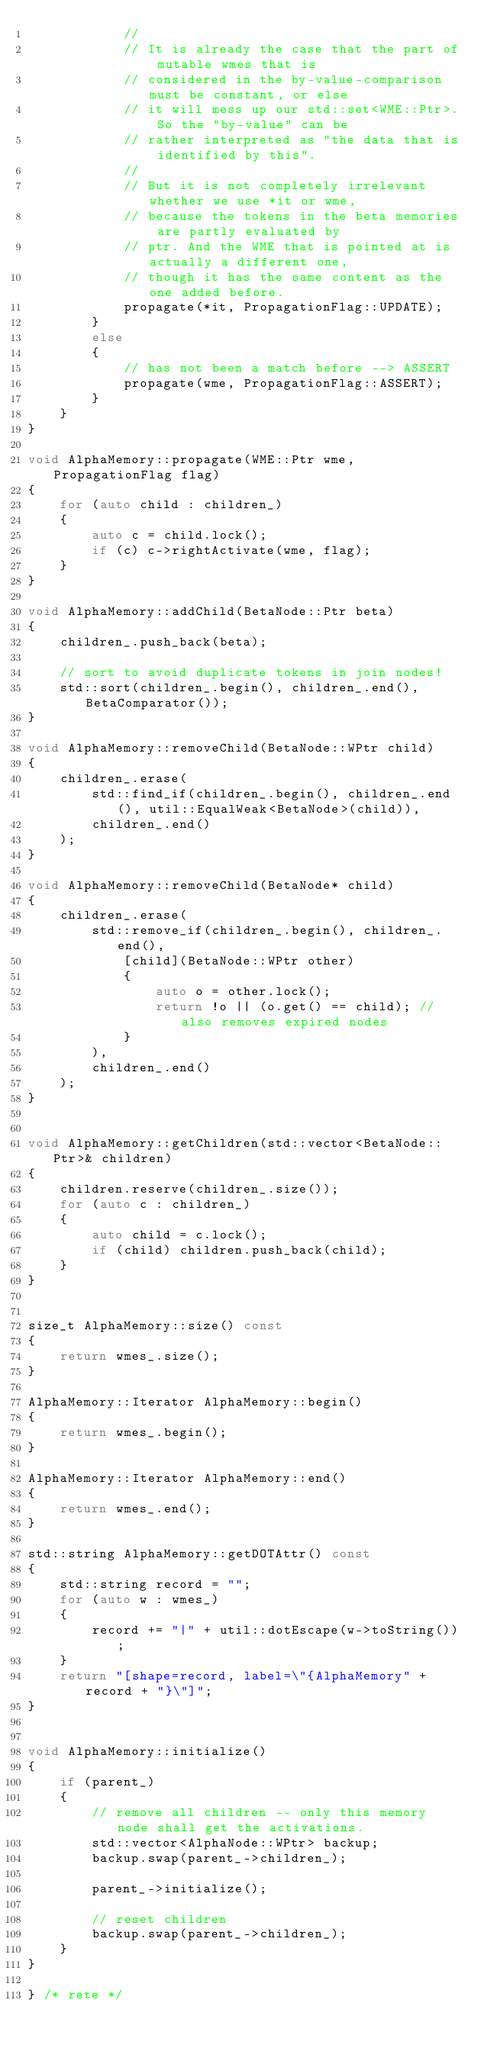<code> <loc_0><loc_0><loc_500><loc_500><_C++_>            //
            // It is already the case that the part of mutable wmes that is
            // considered in the by-value-comparison must be constant, or else
            // it will mess up our std::set<WME::Ptr>. So the "by-value" can be
            // rather interpreted as "the data that is identified by this".
            //
            // But it is not completely irrelevant whether we use *it or wme,
            // because the tokens in the beta memories are partly evaluated by
            // ptr. And the WME that is pointed at is actually a different one,
            // though it has the same content as the one added before.
            propagate(*it, PropagationFlag::UPDATE);
        }
        else
        {
            // has not been a match before --> ASSERT
            propagate(wme, PropagationFlag::ASSERT);
        }
    }
}

void AlphaMemory::propagate(WME::Ptr wme, PropagationFlag flag)
{
    for (auto child : children_)
    {
        auto c = child.lock();
        if (c) c->rightActivate(wme, flag);
    }
}

void AlphaMemory::addChild(BetaNode::Ptr beta)
{
    children_.push_back(beta);

    // sort to avoid duplicate tokens in join nodes!
    std::sort(children_.begin(), children_.end(), BetaComparator());
}

void AlphaMemory::removeChild(BetaNode::WPtr child)
{
    children_.erase(
        std::find_if(children_.begin(), children_.end(), util::EqualWeak<BetaNode>(child)),
        children_.end()
    );
}

void AlphaMemory::removeChild(BetaNode* child)
{
    children_.erase(
        std::remove_if(children_.begin(), children_.end(),
            [child](BetaNode::WPtr other)
            {
                auto o = other.lock();
                return !o || (o.get() == child); // also removes expired nodes
            }
        ),
        children_.end()
    );
}


void AlphaMemory::getChildren(std::vector<BetaNode::Ptr>& children)
{
    children.reserve(children_.size());
    for (auto c : children_)
    {
        auto child = c.lock();
        if (child) children.push_back(child);
    }
}


size_t AlphaMemory::size() const
{
    return wmes_.size();
}

AlphaMemory::Iterator AlphaMemory::begin()
{
    return wmes_.begin();
}

AlphaMemory::Iterator AlphaMemory::end()
{
    return wmes_.end();
}

std::string AlphaMemory::getDOTAttr() const
{
    std::string record = "";
    for (auto w : wmes_)
    {
        record += "|" + util::dotEscape(w->toString());
    }
    return "[shape=record, label=\"{AlphaMemory" + record + "}\"]";
}


void AlphaMemory::initialize()
{
    if (parent_)
    {
        // remove all children -- only this memory node shall get the activations.
        std::vector<AlphaNode::WPtr> backup;
        backup.swap(parent_->children_);

        parent_->initialize();

        // reset children
        backup.swap(parent_->children_);
    }
}

} /* rete */
</code> 